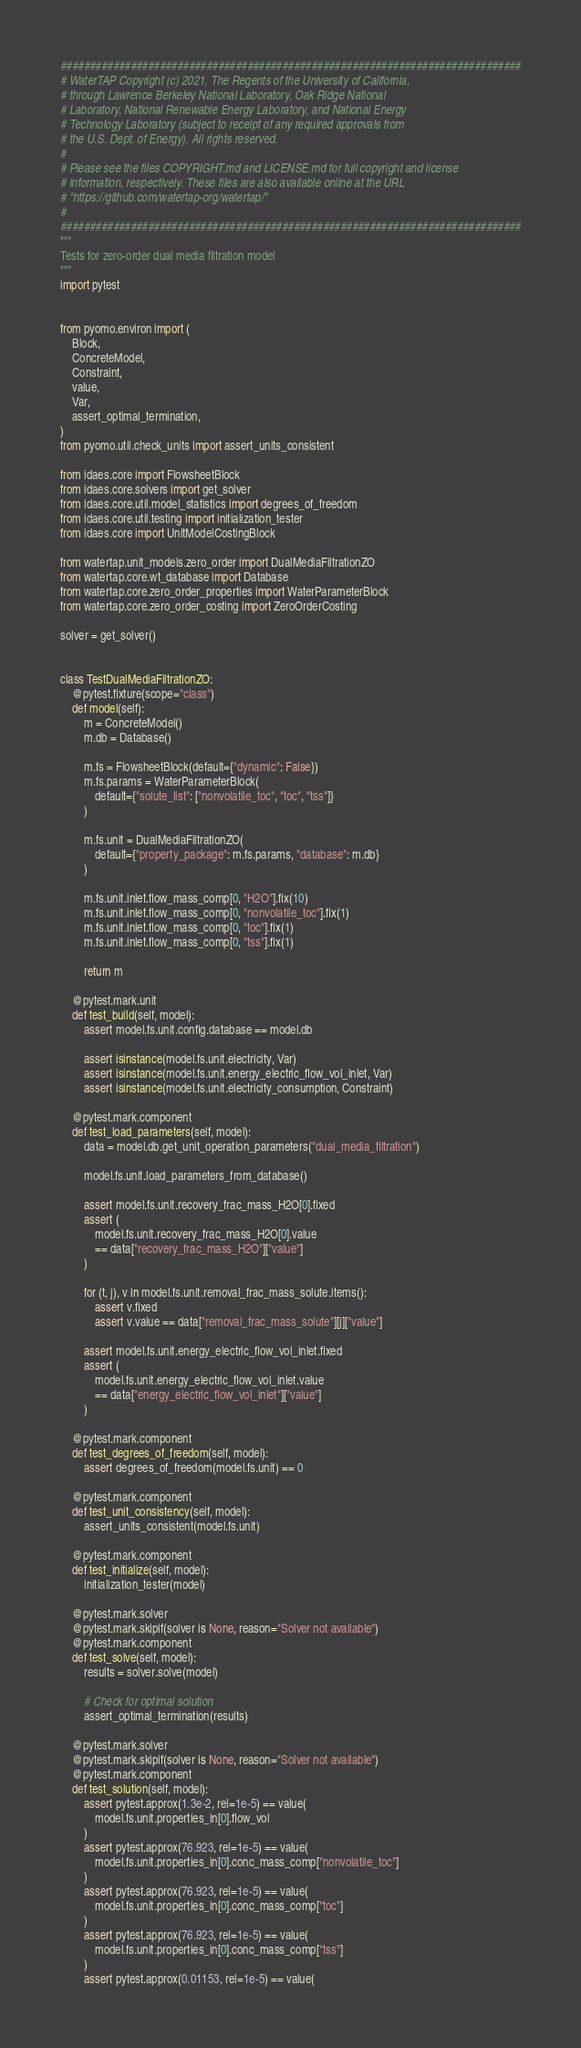<code> <loc_0><loc_0><loc_500><loc_500><_Python_>###############################################################################
# WaterTAP Copyright (c) 2021, The Regents of the University of California,
# through Lawrence Berkeley National Laboratory, Oak Ridge National
# Laboratory, National Renewable Energy Laboratory, and National Energy
# Technology Laboratory (subject to receipt of any required approvals from
# the U.S. Dept. of Energy). All rights reserved.
#
# Please see the files COPYRIGHT.md and LICENSE.md for full copyright and license
# information, respectively. These files are also available online at the URL
# "https://github.com/watertap-org/watertap/"
#
###############################################################################
"""
Tests for zero-order dual media filtration model
"""
import pytest


from pyomo.environ import (
    Block,
    ConcreteModel,
    Constraint,
    value,
    Var,
    assert_optimal_termination,
)
from pyomo.util.check_units import assert_units_consistent

from idaes.core import FlowsheetBlock
from idaes.core.solvers import get_solver
from idaes.core.util.model_statistics import degrees_of_freedom
from idaes.core.util.testing import initialization_tester
from idaes.core import UnitModelCostingBlock

from watertap.unit_models.zero_order import DualMediaFiltrationZO
from watertap.core.wt_database import Database
from watertap.core.zero_order_properties import WaterParameterBlock
from watertap.core.zero_order_costing import ZeroOrderCosting

solver = get_solver()


class TestDualMediaFiltrationZO:
    @pytest.fixture(scope="class")
    def model(self):
        m = ConcreteModel()
        m.db = Database()

        m.fs = FlowsheetBlock(default={"dynamic": False})
        m.fs.params = WaterParameterBlock(
            default={"solute_list": ["nonvolatile_toc", "toc", "tss"]}
        )

        m.fs.unit = DualMediaFiltrationZO(
            default={"property_package": m.fs.params, "database": m.db}
        )

        m.fs.unit.inlet.flow_mass_comp[0, "H2O"].fix(10)
        m.fs.unit.inlet.flow_mass_comp[0, "nonvolatile_toc"].fix(1)
        m.fs.unit.inlet.flow_mass_comp[0, "toc"].fix(1)
        m.fs.unit.inlet.flow_mass_comp[0, "tss"].fix(1)

        return m

    @pytest.mark.unit
    def test_build(self, model):
        assert model.fs.unit.config.database == model.db

        assert isinstance(model.fs.unit.electricity, Var)
        assert isinstance(model.fs.unit.energy_electric_flow_vol_inlet, Var)
        assert isinstance(model.fs.unit.electricity_consumption, Constraint)

    @pytest.mark.component
    def test_load_parameters(self, model):
        data = model.db.get_unit_operation_parameters("dual_media_filtration")

        model.fs.unit.load_parameters_from_database()

        assert model.fs.unit.recovery_frac_mass_H2O[0].fixed
        assert (
            model.fs.unit.recovery_frac_mass_H2O[0].value
            == data["recovery_frac_mass_H2O"]["value"]
        )

        for (t, j), v in model.fs.unit.removal_frac_mass_solute.items():
            assert v.fixed
            assert v.value == data["removal_frac_mass_solute"][j]["value"]

        assert model.fs.unit.energy_electric_flow_vol_inlet.fixed
        assert (
            model.fs.unit.energy_electric_flow_vol_inlet.value
            == data["energy_electric_flow_vol_inlet"]["value"]
        )

    @pytest.mark.component
    def test_degrees_of_freedom(self, model):
        assert degrees_of_freedom(model.fs.unit) == 0

    @pytest.mark.component
    def test_unit_consistency(self, model):
        assert_units_consistent(model.fs.unit)

    @pytest.mark.component
    def test_initialize(self, model):
        initialization_tester(model)

    @pytest.mark.solver
    @pytest.mark.skipif(solver is None, reason="Solver not available")
    @pytest.mark.component
    def test_solve(self, model):
        results = solver.solve(model)

        # Check for optimal solution
        assert_optimal_termination(results)

    @pytest.mark.solver
    @pytest.mark.skipif(solver is None, reason="Solver not available")
    @pytest.mark.component
    def test_solution(self, model):
        assert pytest.approx(1.3e-2, rel=1e-5) == value(
            model.fs.unit.properties_in[0].flow_vol
        )
        assert pytest.approx(76.923, rel=1e-5) == value(
            model.fs.unit.properties_in[0].conc_mass_comp["nonvolatile_toc"]
        )
        assert pytest.approx(76.923, rel=1e-5) == value(
            model.fs.unit.properties_in[0].conc_mass_comp["toc"]
        )
        assert pytest.approx(76.923, rel=1e-5) == value(
            model.fs.unit.properties_in[0].conc_mass_comp["tss"]
        )
        assert pytest.approx(0.01153, rel=1e-5) == value(</code> 